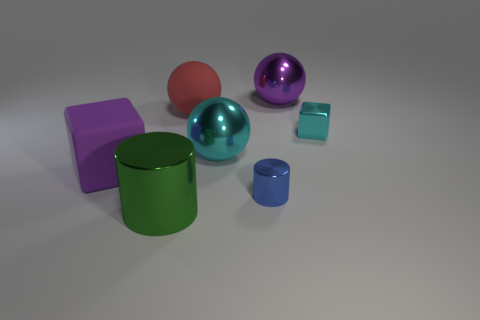Subtract all purple cubes. Subtract all cyan spheres. How many cubes are left? 1 Add 1 big rubber cubes. How many objects exist? 8 Subtract all cubes. How many objects are left? 5 Add 6 matte spheres. How many matte spheres are left? 7 Add 6 large cyan matte cubes. How many large cyan matte cubes exist? 6 Subtract 0 blue blocks. How many objects are left? 7 Subtract all big purple things. Subtract all large spheres. How many objects are left? 2 